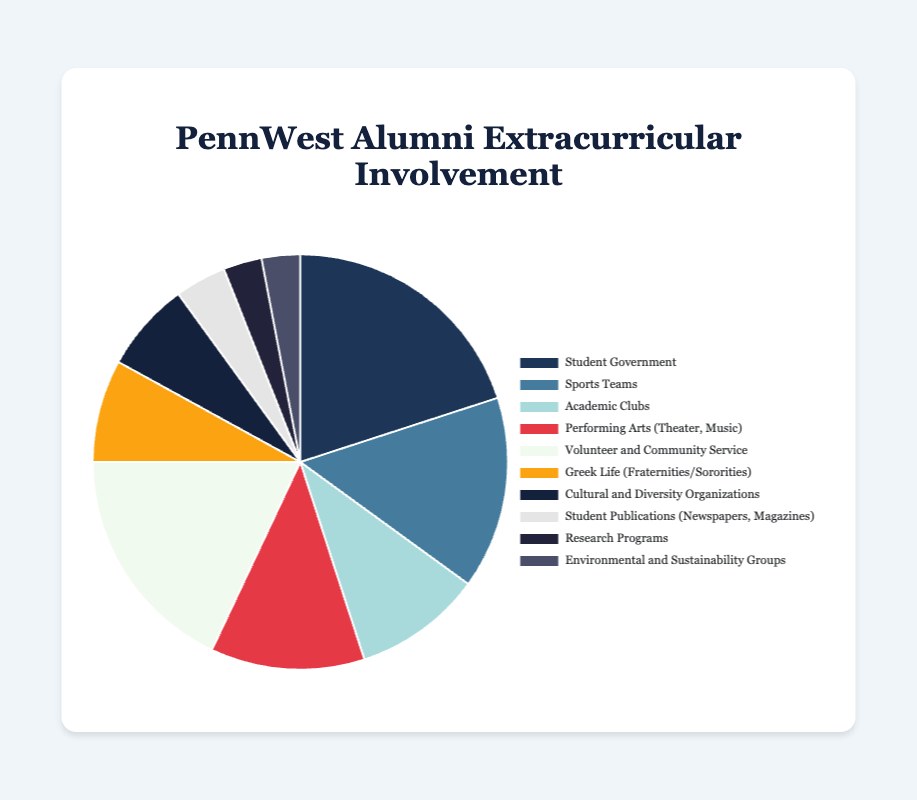What percentage of alumni were involved in Student Government and Academic Clubs combined? The percentage of alumni involved in Student Government is 20%, and the percentage involved in Academic Clubs is 10%. Adding these two percentages together gives 20% + 10% = 30%.
Answer: 30% Which activity had a higher percentage of involvement, Sports Teams or Volunteer and Community Service? The percentage of alumni involved in Sports Teams is 15%, while the percentage involved in Volunteer and Community Service is 18%. Since 18% is greater than 15%, Volunteer and Community Service had a higher percentage of involvement.
Answer: Volunteer and Community Service Which activities had the same percentage of involvement? According to the data, Research Programs and Environmental and Sustainability Groups both had 3% involvement.
Answer: Research Programs and Environmental and Sustainability Groups What is the total percentage of alumni involved in Greek Life, Cultural and Diversity Organizations, and Student Publications? The percentage of alumni involved in Greek Life is 8%, in Cultural and Diversity Organizations is 7%, and in Student Publications is 4%. Summing these percentages gives 8% + 7% + 4% = 19%.
Answer: 19% What color represents Student Government on the pie chart? The color representing Student Government in the pie chart is the first color in the palette provided, which is '#1d3557'. This is a shade of blue.
Answer: Blue What is the percentage difference between the involvement in Sports Teams and Performing Arts? The percentage of alumni involved in Sports Teams is 15%, and in Performing Arts is 12%. The difference between these percentages is 15% - 12% = 3%.
Answer: 3% Which activity had the lowest percentage of involvement? Three activities have the lowest percentage of involvement at 3% each: Research Programs, and Environmental and Sustainability Groups.
Answer: Research Programs and Environmental and Sustainability Groups If an alum was involved in two activities, and one of them was Academic Clubs, what is the combined percentage if their other activity was Volunteer and Community Service? The percentage of alumni involved in Academic Clubs is 10%, and in Volunteer and Community Service is 18%. Summing these percentages gives 10% + 18% = 28%.
Answer: 28% Is the percentage of alumni involved in Sports Teams greater than the combined percentage of those in Greek Life and Cultural and Diversity Organizations? The percentage of alumni involved in Sports Teams is 15%. The combined percentage for Greek Life (8%) and Cultural and Diversity Organizations (7%) is 8% + 7% = 15%. Since both are equal, Sports Teams is not greater.
Answer: No, they are equal What percentage of alumni was involved in non-academic activities if Student Government, Academic Clubs, and Research Programs are considered academic? The non-academic activities include Sports Teams (15%), Performing Arts (12%), Volunteer and Community Service (18%), Greek Life (8%), Cultural and Diversity Organizations (7%), Student Publications (4%), and Environmental and Sustainability Groups (3%). Summing these percentages gives 15% + 12% + 18% + 8% + 7% + 4% + 3% = 67%.
Answer: 67% 